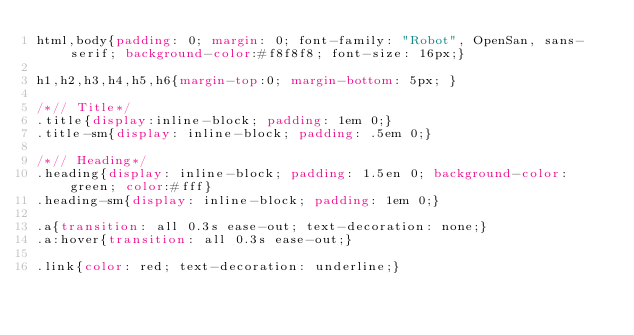<code> <loc_0><loc_0><loc_500><loc_500><_CSS_>html,body{padding: 0; margin: 0; font-family: "Robot", OpenSan, sans-serif; background-color:#f8f8f8; font-size: 16px;}

h1,h2,h3,h4,h5,h6{margin-top:0; margin-bottom: 5px; }

/*// Title*/
.title{display:inline-block; padding: 1em 0;}
.title-sm{display: inline-block; padding: .5em 0;}

/*// Heading*/
.heading{display: inline-block; padding: 1.5en 0; background-color: green; color:#fff}
.heading-sm{display: inline-block; padding: 1em 0;}

.a{transition: all 0.3s ease-out; text-decoration: none;}
.a:hover{transition: all 0.3s ease-out;}

.link{color: red; text-decoration: underline;}

</code> 